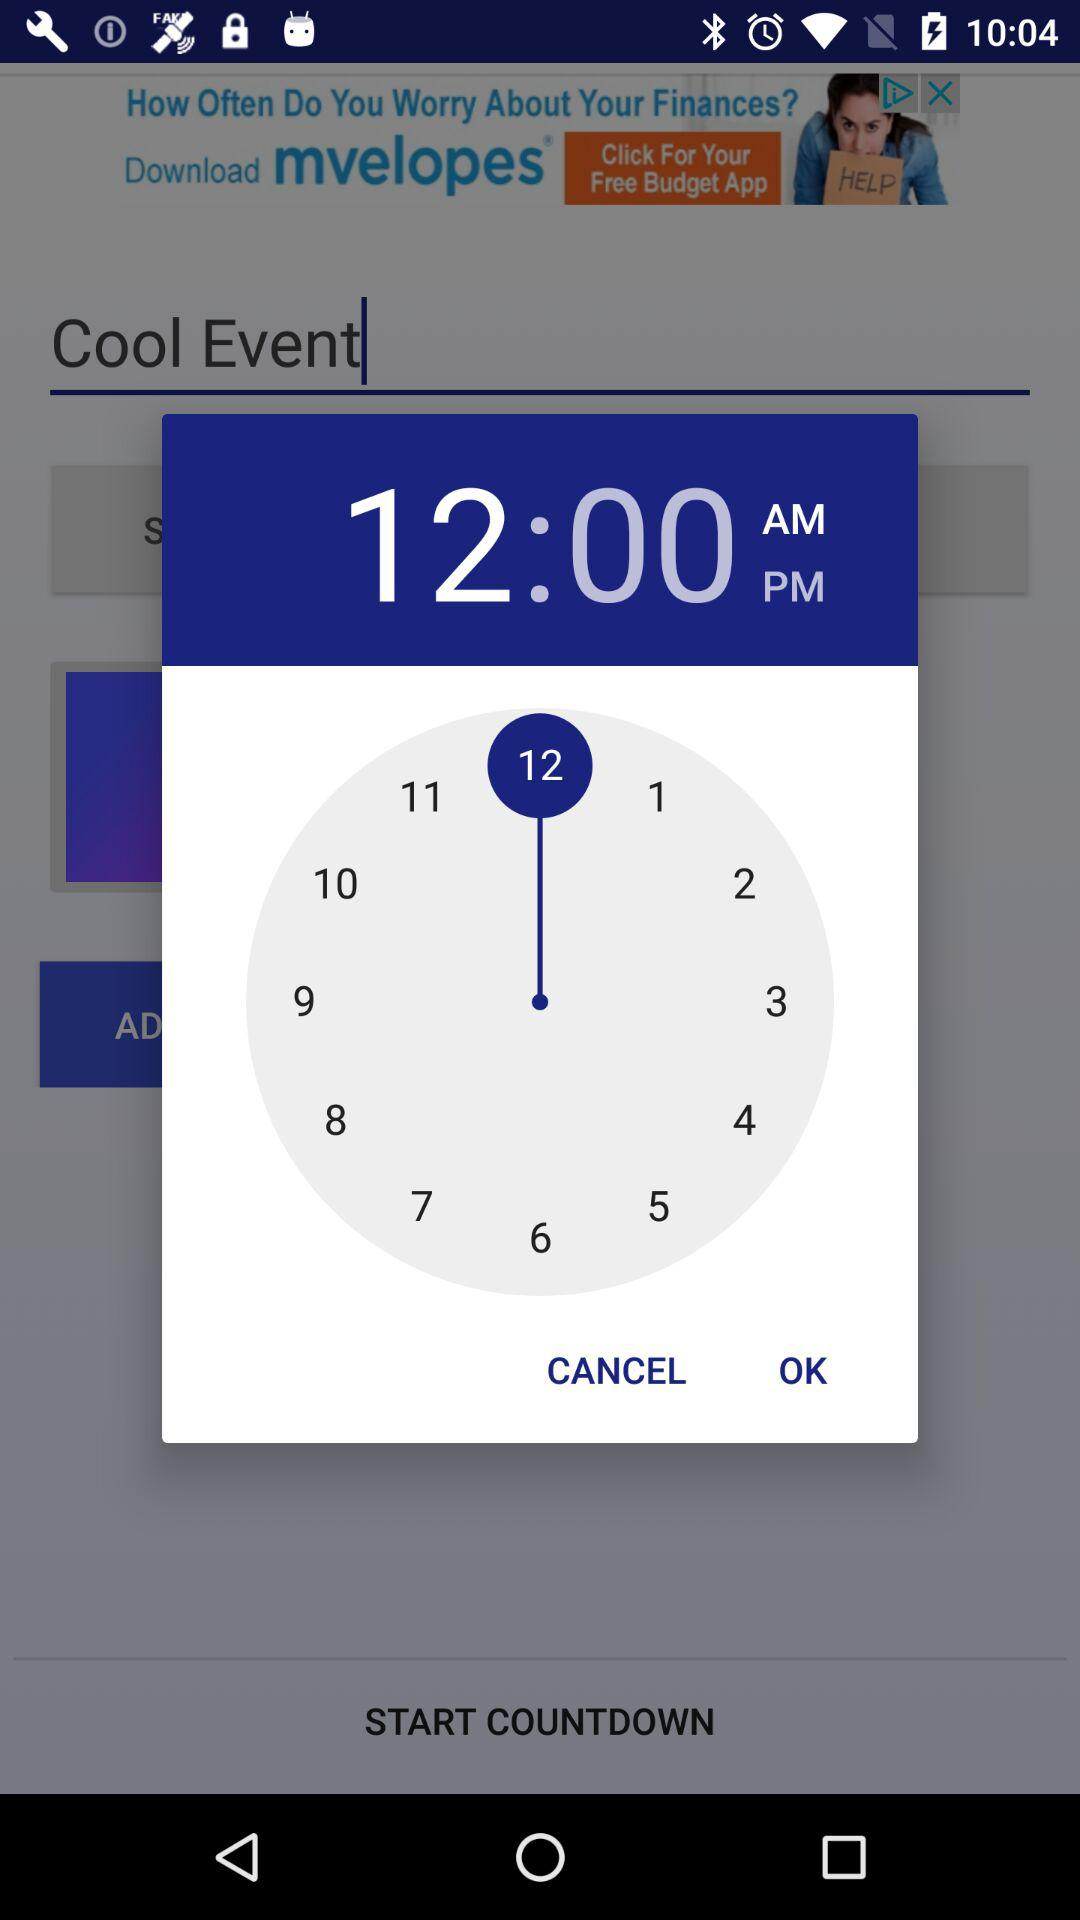What is the name of the event? The name of the event is "Cool Event". 